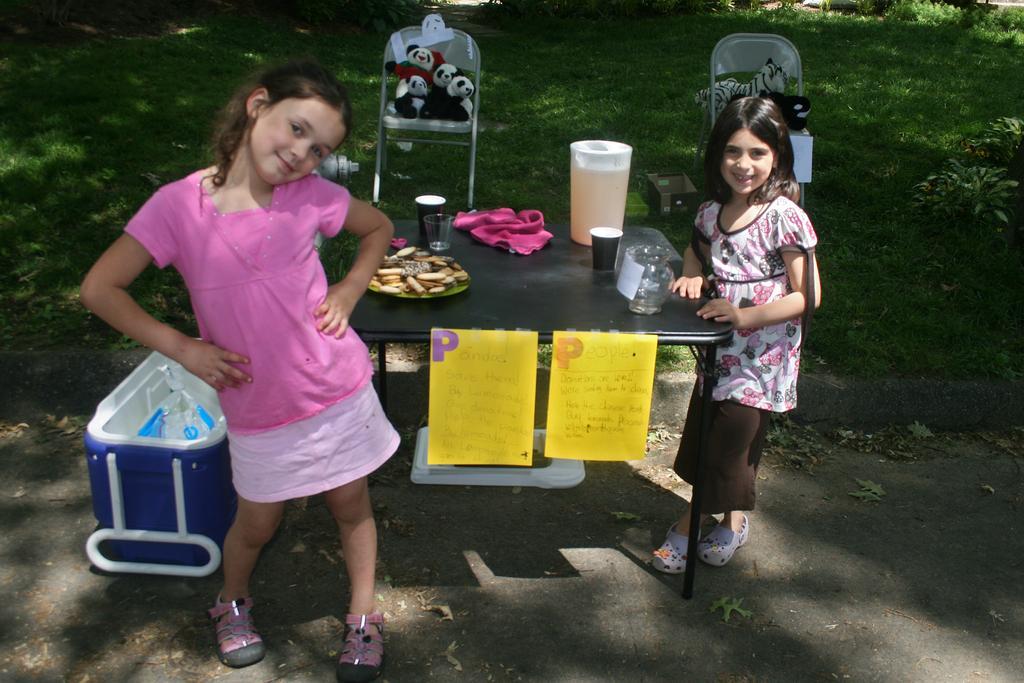Can you describe this image briefly? In this picture we can see 2 girls who are looking at camera and here we have black table on which we have jar containing liquid, some cloth and some food items. On top of table there is a paper on which some matter is written and here we can see some tub. It looks like road, in the background we can see grass and we have 2 chairs, on the chairs we have teddy bears. 